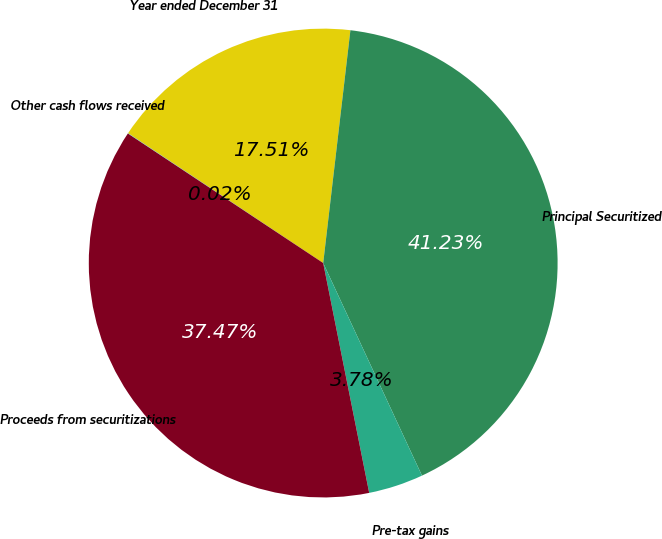Convert chart. <chart><loc_0><loc_0><loc_500><loc_500><pie_chart><fcel>Year ended December 31<fcel>Principal Securitized<fcel>Pre-tax gains<fcel>Proceeds from securitizations<fcel>Other cash flows received<nl><fcel>17.51%<fcel>41.23%<fcel>3.78%<fcel>37.47%<fcel>0.02%<nl></chart> 